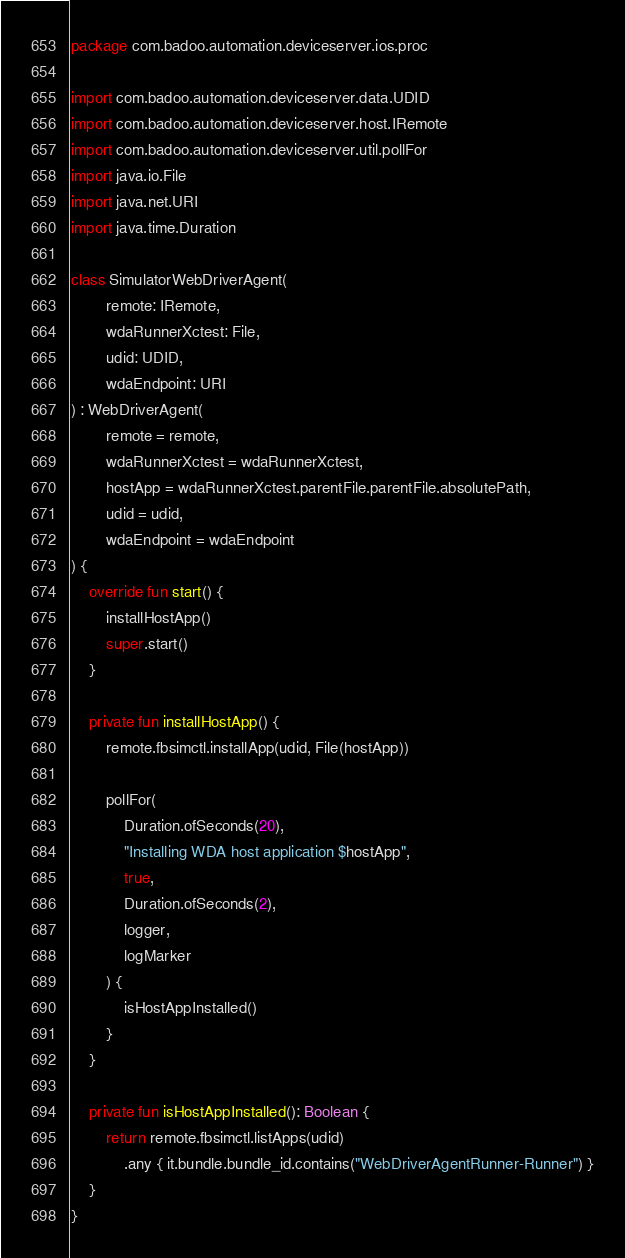Convert code to text. <code><loc_0><loc_0><loc_500><loc_500><_Kotlin_>package com.badoo.automation.deviceserver.ios.proc

import com.badoo.automation.deviceserver.data.UDID
import com.badoo.automation.deviceserver.host.IRemote
import com.badoo.automation.deviceserver.util.pollFor
import java.io.File
import java.net.URI
import java.time.Duration

class SimulatorWebDriverAgent(
        remote: IRemote,
        wdaRunnerXctest: File,
        udid: UDID,
        wdaEndpoint: URI
) : WebDriverAgent(
        remote = remote,
        wdaRunnerXctest = wdaRunnerXctest,
        hostApp = wdaRunnerXctest.parentFile.parentFile.absolutePath,
        udid = udid,
        wdaEndpoint = wdaEndpoint
) {
    override fun start() {
        installHostApp()
        super.start()
    }

    private fun installHostApp() {
        remote.fbsimctl.installApp(udid, File(hostApp))

        pollFor(
            Duration.ofSeconds(20),
            "Installing WDA host application $hostApp",
            true,
            Duration.ofSeconds(2),
            logger,
            logMarker
        ) {
            isHostAppInstalled()
        }
    }

    private fun isHostAppInstalled(): Boolean {
        return remote.fbsimctl.listApps(udid)
            .any { it.bundle.bundle_id.contains("WebDriverAgentRunner-Runner") }
    }
}</code> 